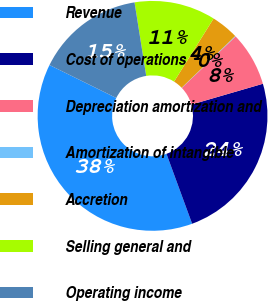Convert chart to OTSL. <chart><loc_0><loc_0><loc_500><loc_500><pie_chart><fcel>Revenue<fcel>Cost of operations<fcel>Depreciation amortization and<fcel>Amortization of intangible<fcel>Accretion<fcel>Selling general and<fcel>Operating income<nl><fcel>37.89%<fcel>23.91%<fcel>7.64%<fcel>0.08%<fcel>3.86%<fcel>11.42%<fcel>15.2%<nl></chart> 